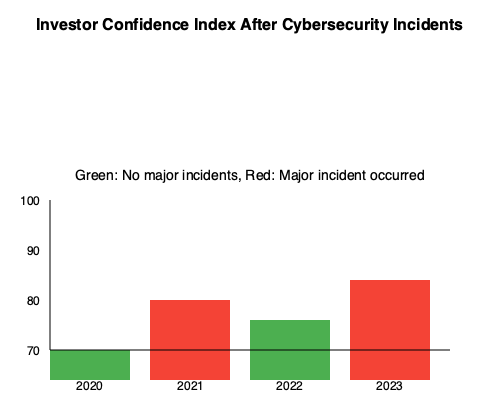Based on the bar chart showing investor confidence levels after cybersecurity incidents from 2020 to 2023, what can be inferred about the relationship between major cybersecurity incidents and investor confidence? To answer this question, let's analyze the data presented in the bar chart step by step:

1. The chart shows investor confidence levels for four years (2020-2023).
2. Green bars represent years with no major cybersecurity incidents, while red bars indicate years when a major incident occurred.
3. Let's examine each year:
   - 2020 (green): Confidence level at 70
   - 2021 (red): Confidence level at 80
   - 2022 (green): Confidence level at 60
   - 2023 (red): Confidence level at 100

4. Comparing the years:
   - The two years without major incidents (2020 and 2022) show lower confidence levels (70 and 60) compared to the years with incidents.
   - The two years with major incidents (2021 and 2023) show higher confidence levels (80 and 100).

5. This pattern suggests an unexpected relationship: investor confidence appears to be higher in years following major cybersecurity incidents.

6. Possible explanations for this counterintuitive trend could include:
   - Increased cybersecurity measures implemented after incidents, leading to improved investor trust.
   - Greater transparency and communication from companies following incidents, boosting investor confidence.
   - Market resilience and quick recovery after cybersecurity events, demonstrating strength to investors.

7. It's important to note that this is a simplified representation and other factors could be influencing investor confidence besides cybersecurity incidents.

Based on this analysis, we can infer that there is a positive correlation between major cybersecurity incidents and subsequent investor confidence levels, contrary to what might be initially expected.
Answer: Positive correlation between major cybersecurity incidents and investor confidence 